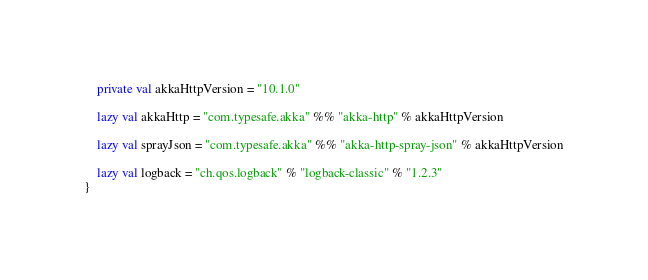Convert code to text. <code><loc_0><loc_0><loc_500><loc_500><_Scala_>
	private val akkaHttpVersion = "10.1.0"

	lazy val akkaHttp = "com.typesafe.akka" %% "akka-http" % akkaHttpVersion

	lazy val sprayJson = "com.typesafe.akka" %% "akka-http-spray-json" % akkaHttpVersion

	lazy val logback = "ch.qos.logback" % "logback-classic" % "1.2.3"
}
</code> 